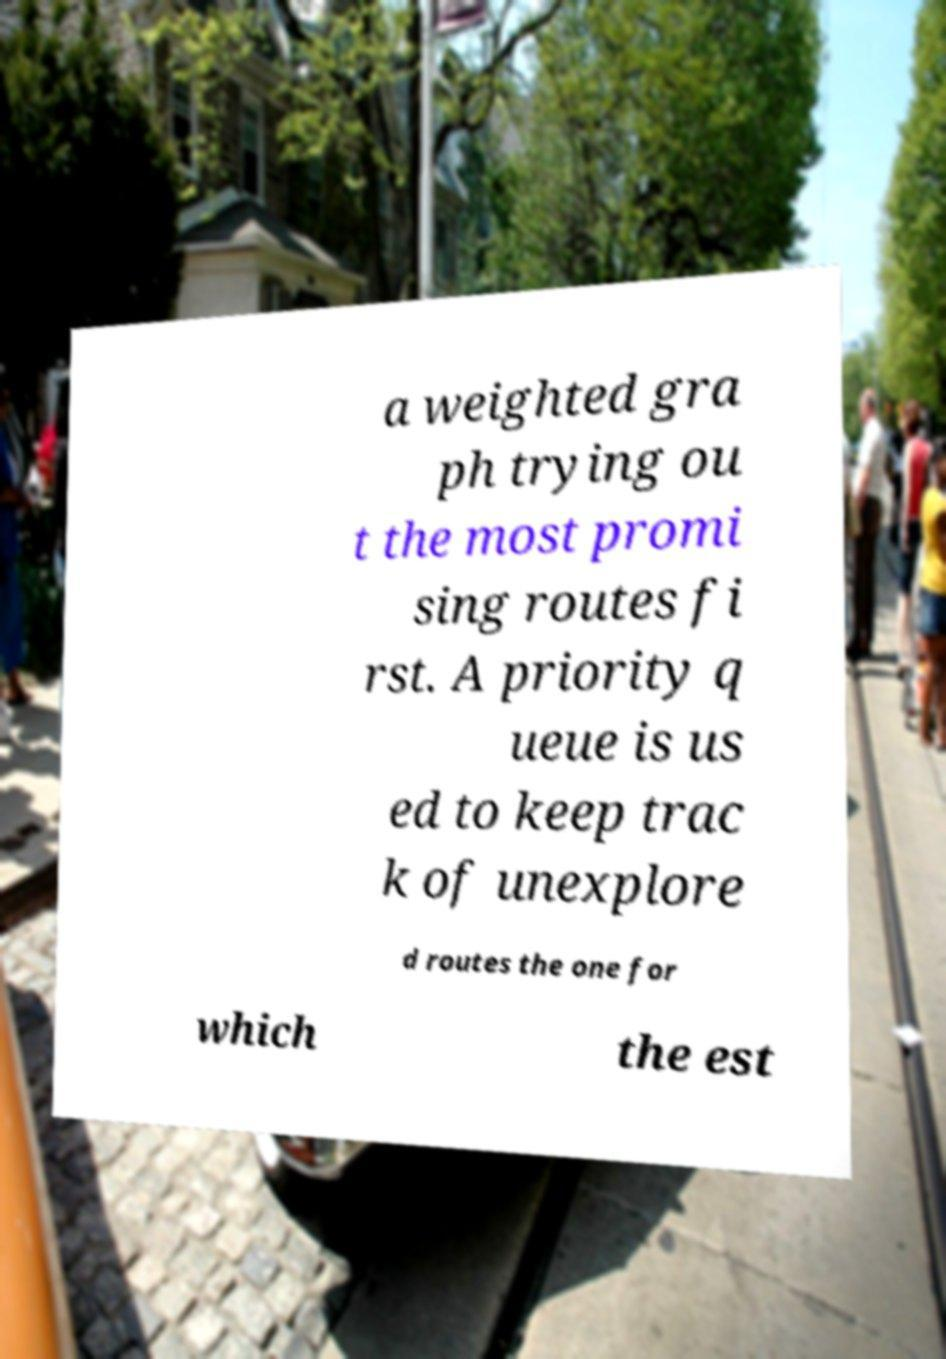Please read and relay the text visible in this image. What does it say? a weighted gra ph trying ou t the most promi sing routes fi rst. A priority q ueue is us ed to keep trac k of unexplore d routes the one for which the est 